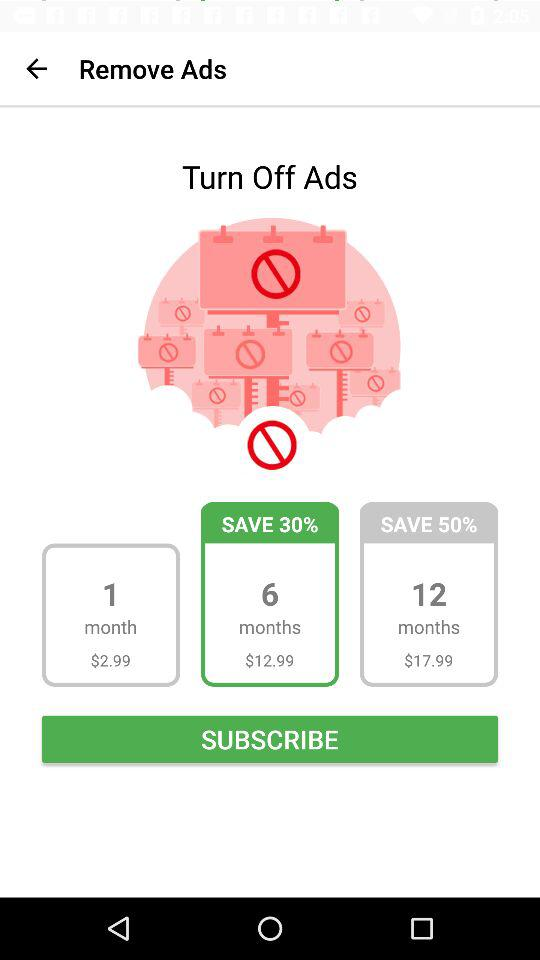How much is the monthly subscription for 12 months?
Answer the question using a single word or phrase. $17.99 